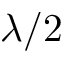Convert formula to latex. <formula><loc_0><loc_0><loc_500><loc_500>\lambda / 2</formula> 